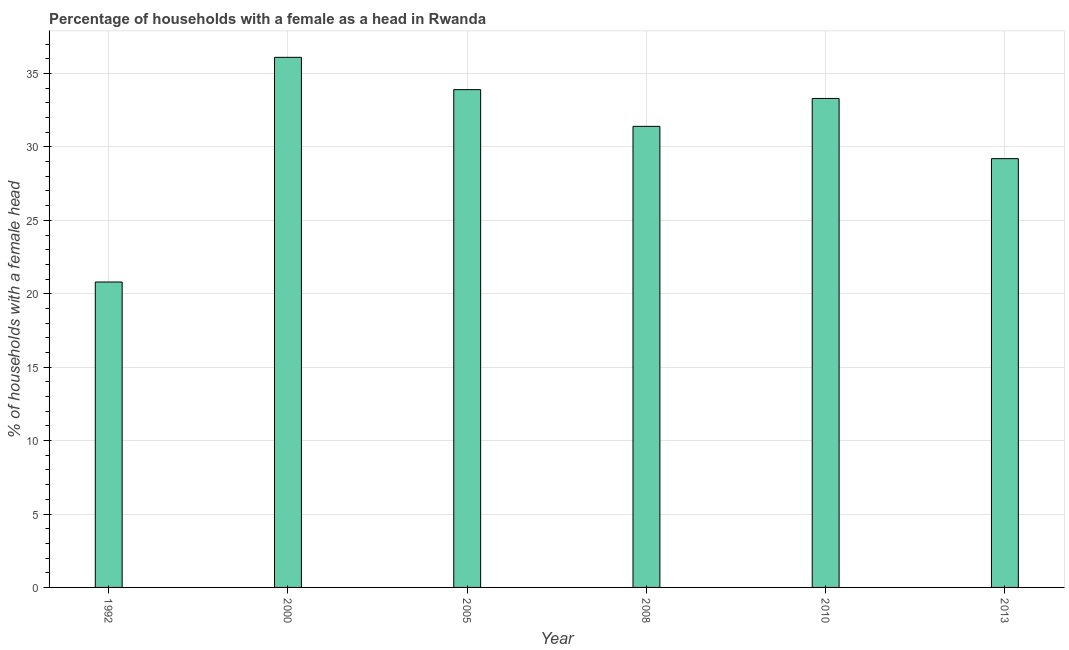Does the graph contain grids?
Your answer should be compact. Yes. What is the title of the graph?
Ensure brevity in your answer.  Percentage of households with a female as a head in Rwanda. What is the label or title of the Y-axis?
Offer a very short reply. % of households with a female head. What is the number of female supervised households in 2013?
Provide a short and direct response. 29.2. Across all years, what is the maximum number of female supervised households?
Your answer should be very brief. 36.1. Across all years, what is the minimum number of female supervised households?
Provide a short and direct response. 20.8. In which year was the number of female supervised households minimum?
Make the answer very short. 1992. What is the sum of the number of female supervised households?
Give a very brief answer. 184.7. What is the average number of female supervised households per year?
Your answer should be compact. 30.78. What is the median number of female supervised households?
Provide a succinct answer. 32.35. What is the ratio of the number of female supervised households in 2000 to that in 2005?
Your answer should be compact. 1.06. Is the number of female supervised households in 2008 less than that in 2013?
Keep it short and to the point. No. Is the difference between the number of female supervised households in 2008 and 2010 greater than the difference between any two years?
Your response must be concise. No. Is the sum of the number of female supervised households in 2000 and 2008 greater than the maximum number of female supervised households across all years?
Your response must be concise. Yes. In how many years, is the number of female supervised households greater than the average number of female supervised households taken over all years?
Offer a very short reply. 4. Are all the bars in the graph horizontal?
Give a very brief answer. No. How many years are there in the graph?
Offer a very short reply. 6. What is the % of households with a female head of 1992?
Offer a very short reply. 20.8. What is the % of households with a female head of 2000?
Ensure brevity in your answer.  36.1. What is the % of households with a female head in 2005?
Your answer should be compact. 33.9. What is the % of households with a female head in 2008?
Provide a short and direct response. 31.4. What is the % of households with a female head of 2010?
Provide a short and direct response. 33.3. What is the % of households with a female head in 2013?
Give a very brief answer. 29.2. What is the difference between the % of households with a female head in 1992 and 2000?
Your answer should be very brief. -15.3. What is the difference between the % of households with a female head in 1992 and 2008?
Your answer should be very brief. -10.6. What is the difference between the % of households with a female head in 1992 and 2010?
Your response must be concise. -12.5. What is the difference between the % of households with a female head in 2000 and 2005?
Make the answer very short. 2.2. What is the difference between the % of households with a female head in 2000 and 2010?
Give a very brief answer. 2.8. What is the difference between the % of households with a female head in 2005 and 2008?
Your response must be concise. 2.5. What is the difference between the % of households with a female head in 2005 and 2013?
Offer a very short reply. 4.7. What is the difference between the % of households with a female head in 2008 and 2010?
Your answer should be very brief. -1.9. What is the difference between the % of households with a female head in 2008 and 2013?
Ensure brevity in your answer.  2.2. What is the ratio of the % of households with a female head in 1992 to that in 2000?
Your response must be concise. 0.58. What is the ratio of the % of households with a female head in 1992 to that in 2005?
Offer a terse response. 0.61. What is the ratio of the % of households with a female head in 1992 to that in 2008?
Your answer should be very brief. 0.66. What is the ratio of the % of households with a female head in 1992 to that in 2010?
Provide a succinct answer. 0.62. What is the ratio of the % of households with a female head in 1992 to that in 2013?
Keep it short and to the point. 0.71. What is the ratio of the % of households with a female head in 2000 to that in 2005?
Offer a terse response. 1.06. What is the ratio of the % of households with a female head in 2000 to that in 2008?
Keep it short and to the point. 1.15. What is the ratio of the % of households with a female head in 2000 to that in 2010?
Offer a very short reply. 1.08. What is the ratio of the % of households with a female head in 2000 to that in 2013?
Your response must be concise. 1.24. What is the ratio of the % of households with a female head in 2005 to that in 2008?
Ensure brevity in your answer.  1.08. What is the ratio of the % of households with a female head in 2005 to that in 2013?
Your response must be concise. 1.16. What is the ratio of the % of households with a female head in 2008 to that in 2010?
Ensure brevity in your answer.  0.94. What is the ratio of the % of households with a female head in 2008 to that in 2013?
Ensure brevity in your answer.  1.07. What is the ratio of the % of households with a female head in 2010 to that in 2013?
Offer a terse response. 1.14. 